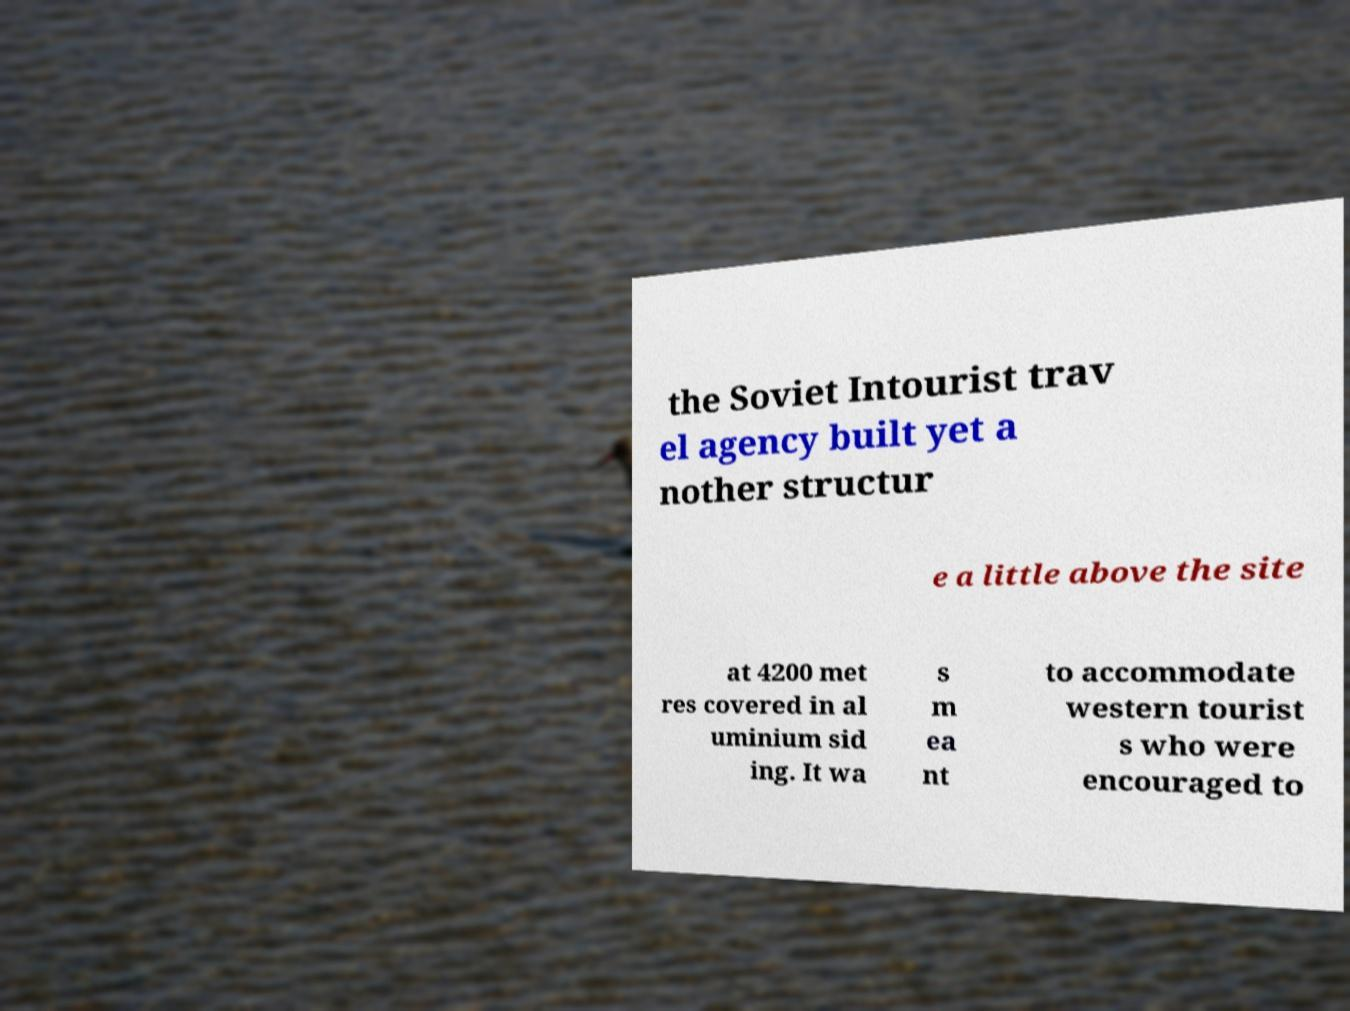Could you assist in decoding the text presented in this image and type it out clearly? the Soviet Intourist trav el agency built yet a nother structur e a little above the site at 4200 met res covered in al uminium sid ing. It wa s m ea nt to accommodate western tourist s who were encouraged to 